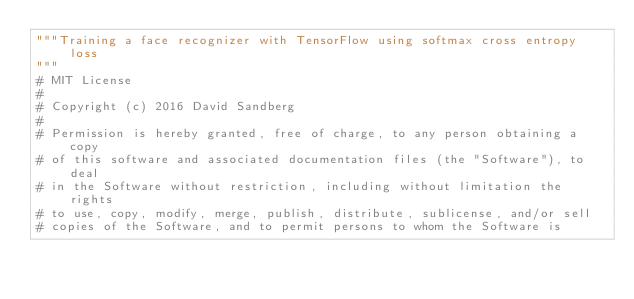Convert code to text. <code><loc_0><loc_0><loc_500><loc_500><_Python_>"""Training a face recognizer with TensorFlow using softmax cross entropy loss
"""
# MIT License
# 
# Copyright (c) 2016 David Sandberg
# 
# Permission is hereby granted, free of charge, to any person obtaining a copy
# of this software and associated documentation files (the "Software"), to deal
# in the Software without restriction, including without limitation the rights
# to use, copy, modify, merge, publish, distribute, sublicense, and/or sell
# copies of the Software, and to permit persons to whom the Software is</code> 